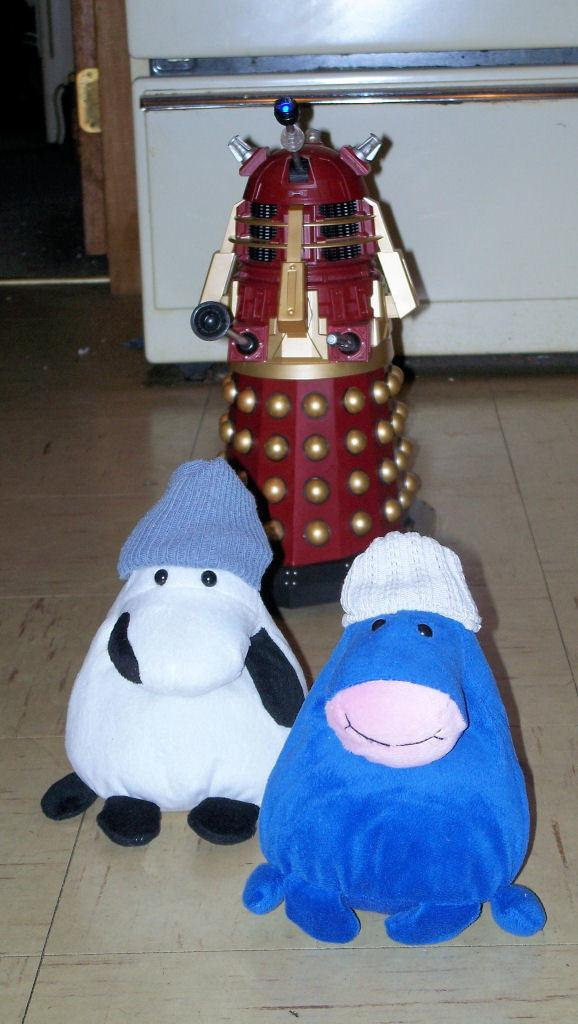What colors are the toys in the image? The toys in the image have white and blue colors. Can you describe another object in the image? There is an object in maroon, black, and cream colors in the image. What color is the object in the background of the image? There is a white color object in the background of the image. How does the mother in the image show respect to the force? There is no mother or force present in the image, so this question cannot be answered. 